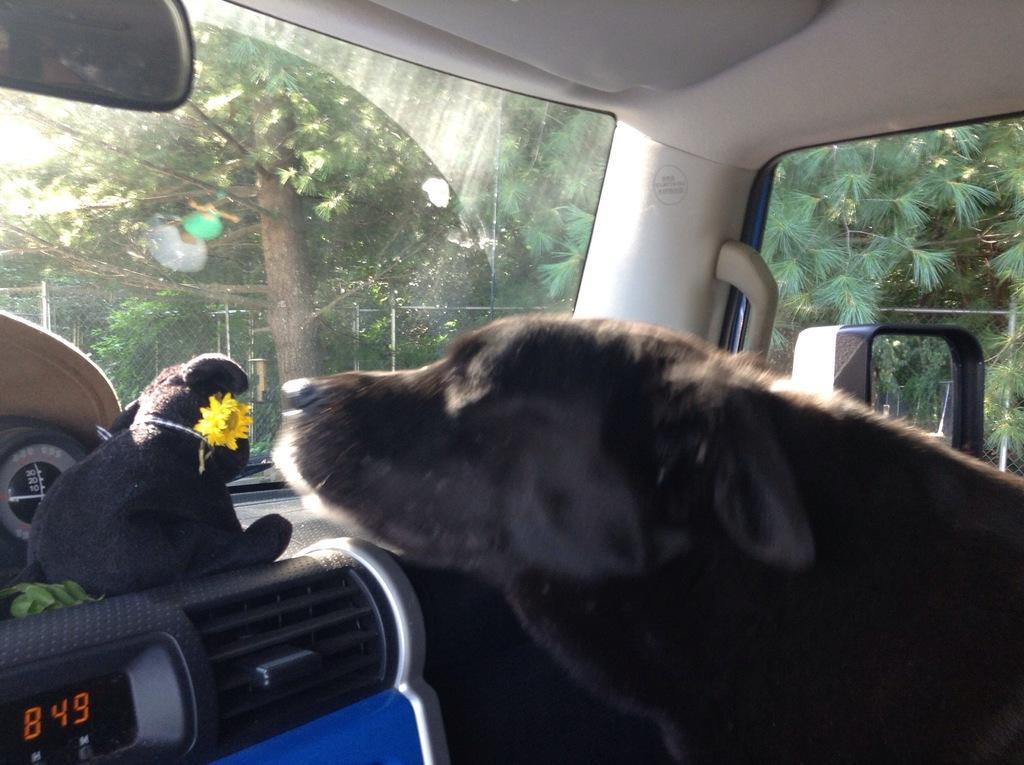Can you describe this image briefly? The photo is taken inside a vehicle. There is a dog, there is glass window, there is vent,there is a soft toy. Outside there are trees. 